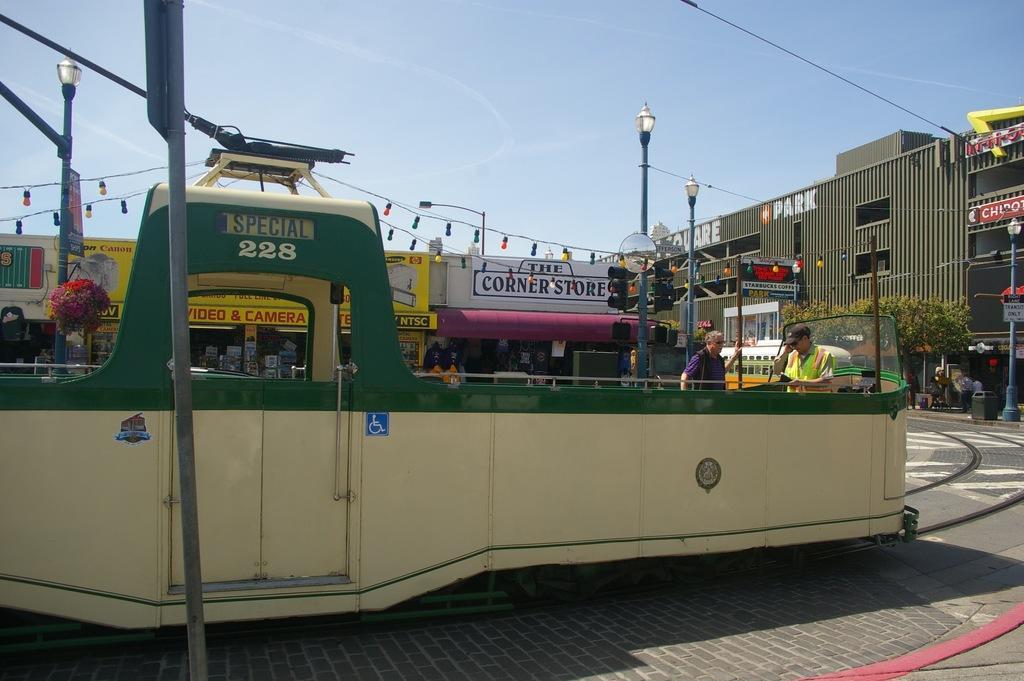Please provide a concise description of this image. In the image we can see there are people wearing clothes. This person is wearing cap, this is a street, trees, light pole, electrical wires, building, poster and a sky. This is a train. 